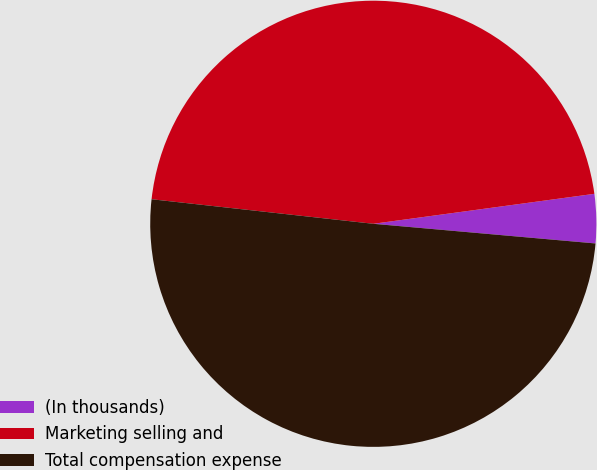<chart> <loc_0><loc_0><loc_500><loc_500><pie_chart><fcel>(In thousands)<fcel>Marketing selling and<fcel>Total compensation expense<nl><fcel>3.55%<fcel>46.1%<fcel>50.35%<nl></chart> 